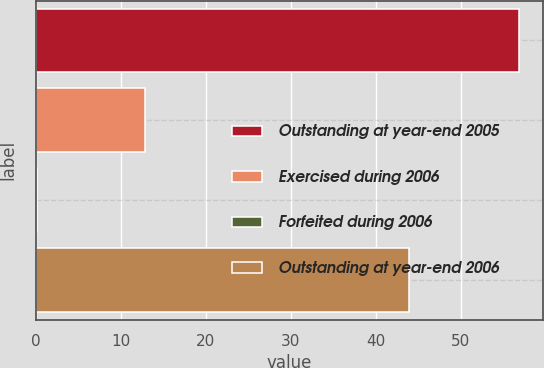Convert chart. <chart><loc_0><loc_0><loc_500><loc_500><bar_chart><fcel>Outstanding at year-end 2005<fcel>Exercised during 2006<fcel>Forfeited during 2006<fcel>Outstanding at year-end 2006<nl><fcel>56.8<fcel>12.8<fcel>0.1<fcel>43.9<nl></chart> 